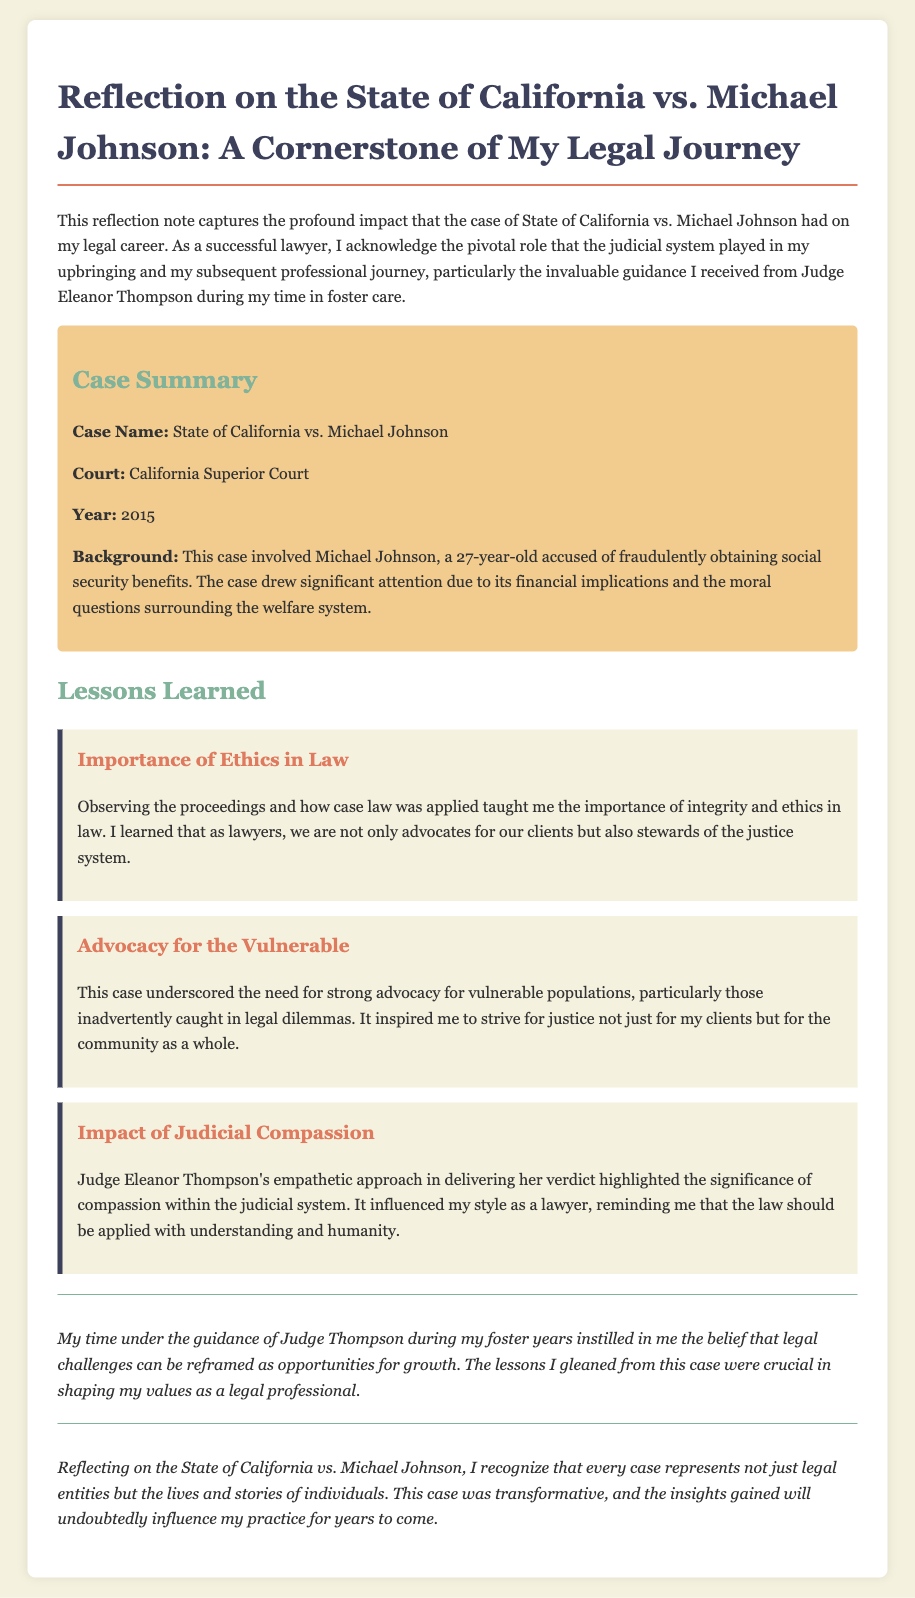What is the case name? The case name is identified at the beginning of the case summary section, which is "State of California vs. Michael Johnson."
Answer: State of California vs. Michael Johnson What year did the case occur? The year of the case is explicitly mentioned in the case summary, listed as 2015.
Answer: 2015 Who was the judge presiding over the case? The document mentions Judge Eleanor Thompson in the context of her influence during the case.
Answer: Judge Eleanor Thompson What was Michael Johnson accused of? The background section specifies that Michael Johnson was accused of fraudulently obtaining social security benefits.
Answer: Fraudulently obtaining social security benefits What lesson is highlighted about judicial compassion? One of the lessons discusses how Judge Thompson's empathetic approach influenced the author's understanding of compassion within the judicial system.
Answer: Compassion within the judicial system What does the author attribute their success as a lawyer to? The author references the guidance and support received from Judge Eleanor Thompson during their time in foster care.
Answer: Guidance and support from Judge Eleanor Thompson What are lawyers described as in relation to the justice system? The author summarises that lawyers are not only advocates for clients but also described as stewards of the justice system.
Answer: Stewards of the justice system What significant understanding did the author gain regarding advocacy? The author learned the importance of advocacy for vulnerable populations caught in legal dilemmas, as indicated in one of the lessons.
Answer: Advocacy for vulnerable populations 